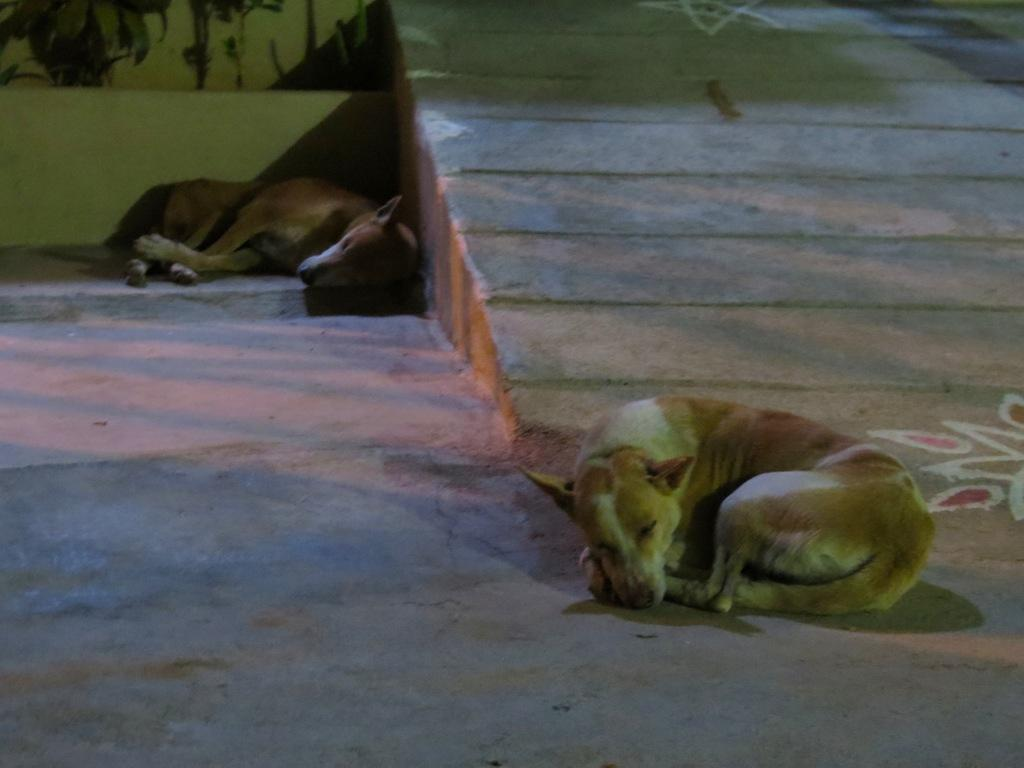Where was the image taken? The image was clicked outside. What animals can be seen in the image? There are two dogs in the image. What are the dogs doing in the image? The dogs are sleeping on the ground. What can be seen in the background of the image? There are leaves visible in the background of the image, as well as other objects. What type of egg is being painted on the canvas in the image? There is no egg or canvas present in the image; it features two dogs sleeping on the ground outside. 